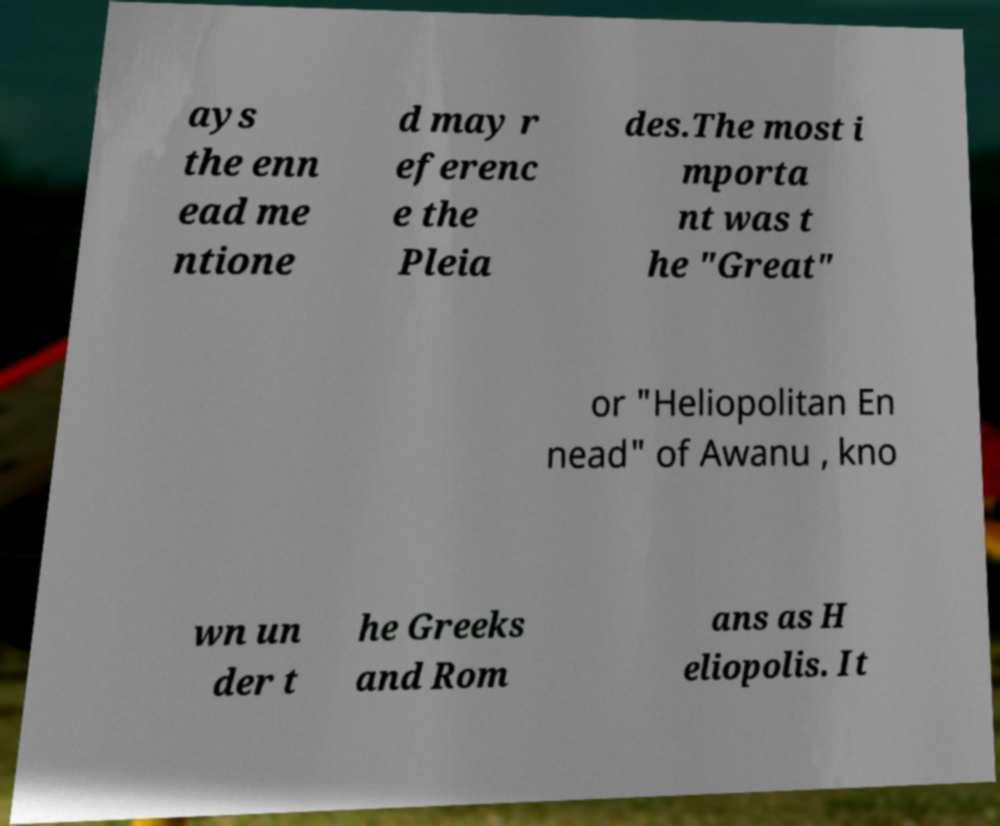What messages or text are displayed in this image? I need them in a readable, typed format. ays the enn ead me ntione d may r eferenc e the Pleia des.The most i mporta nt was t he "Great" or "Heliopolitan En nead" of Awanu , kno wn un der t he Greeks and Rom ans as H eliopolis. It 